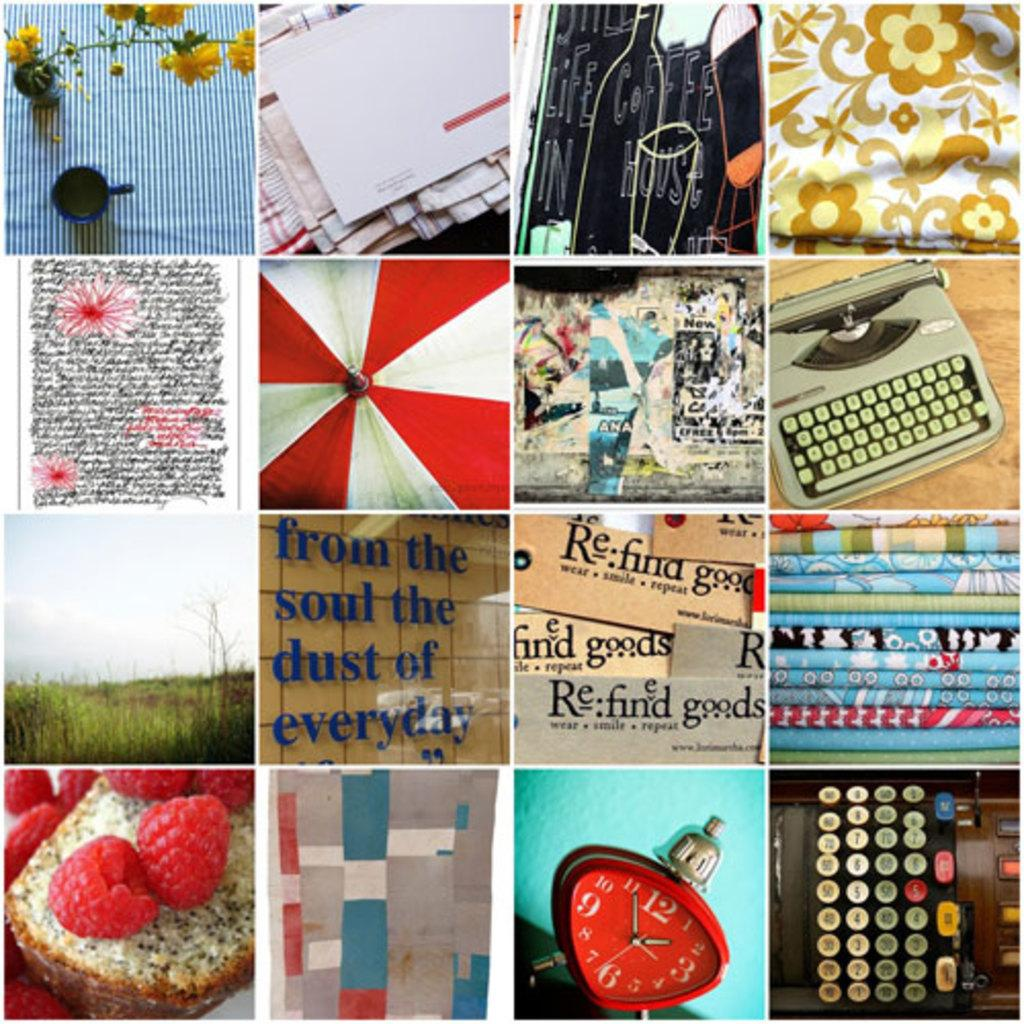<image>
Summarize the visual content of the image. A collage of images includes one with the words from the soul the dust of everyday. 